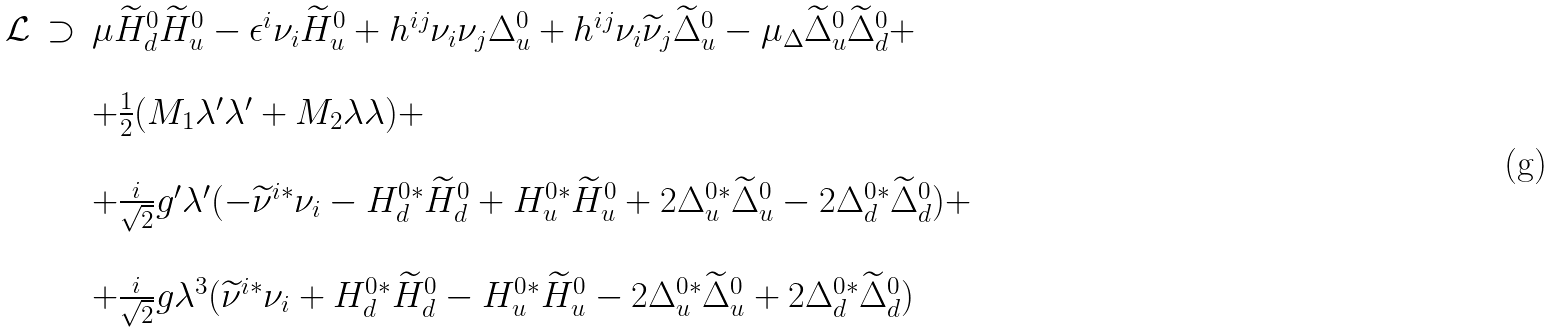Convert formula to latex. <formula><loc_0><loc_0><loc_500><loc_500>\begin{array} { c c l } \mathcal { L } & \supset & \mu \widetilde { H } _ { d } ^ { 0 } \widetilde { H } _ { u } ^ { 0 } - \epsilon ^ { i } \nu _ { i } \widetilde { H } _ { u } ^ { 0 } + h ^ { i j } \nu _ { i } \nu _ { j } \Delta _ { u } ^ { 0 } + h ^ { i j } \nu _ { i } \widetilde { \nu } _ { j } \widetilde { \Delta } _ { u } ^ { 0 } - \mu _ { \Delta } \widetilde { \Delta } _ { u } ^ { 0 } \widetilde { \Delta } _ { d } ^ { 0 } + \\ & & \\ & & + \frac { 1 } { 2 } ( M _ { 1 } \lambda ^ { \prime } \lambda ^ { \prime } + M _ { 2 } \lambda \lambda ) + \\ & & \\ & & + \frac { i } { \sqrt { 2 } } g ^ { \prime } \lambda ^ { \prime } ( - \widetilde { \nu } ^ { i * } \nu _ { i } - H _ { d } ^ { 0 * } \widetilde { H } _ { d } ^ { 0 } + H _ { u } ^ { 0 * } \widetilde { H } _ { u } ^ { 0 } + 2 \Delta _ { u } ^ { 0 * } \widetilde { \Delta } _ { u } ^ { 0 } - 2 \Delta _ { d } ^ { 0 * } \widetilde { \Delta } _ { d } ^ { 0 } ) + \\ & & \\ & & + \frac { i } { \sqrt { 2 } } g \lambda ^ { 3 } ( \widetilde { \nu } ^ { i * } \nu _ { i } + H _ { d } ^ { 0 * } \widetilde { H } _ { d } ^ { 0 } - H _ { u } ^ { 0 * } \widetilde { H } _ { u } ^ { 0 } - 2 \Delta _ { u } ^ { 0 * } \widetilde { \Delta } _ { u } ^ { 0 } + 2 \Delta _ { d } ^ { 0 * } \widetilde { \Delta } _ { d } ^ { 0 } ) \end{array}</formula> 